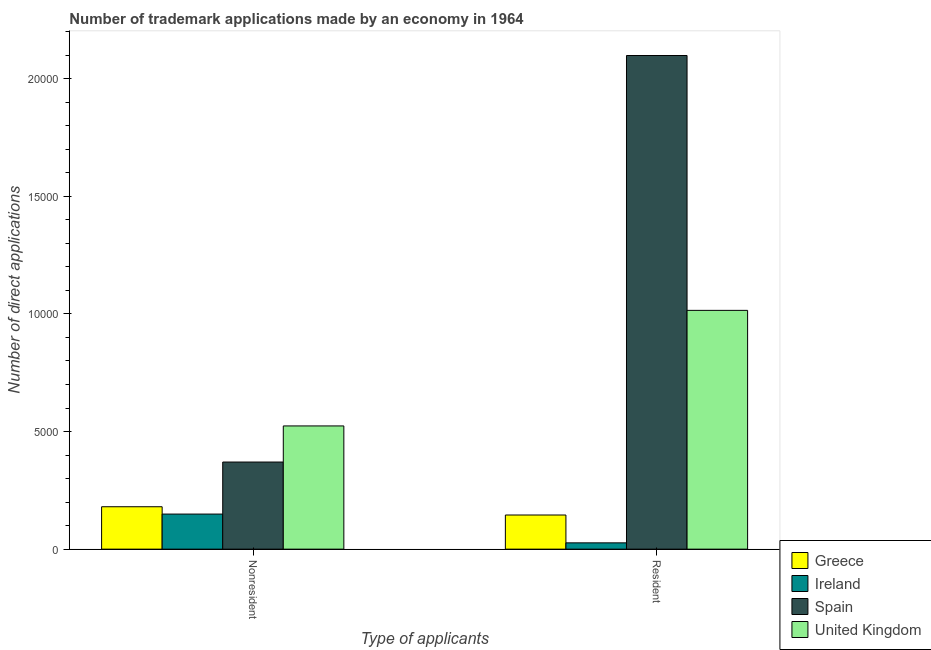How many groups of bars are there?
Provide a succinct answer. 2. Are the number of bars on each tick of the X-axis equal?
Offer a terse response. Yes. How many bars are there on the 2nd tick from the left?
Provide a succinct answer. 4. What is the label of the 2nd group of bars from the left?
Keep it short and to the point. Resident. What is the number of trademark applications made by non residents in Ireland?
Make the answer very short. 1491. Across all countries, what is the maximum number of trademark applications made by non residents?
Make the answer very short. 5238. Across all countries, what is the minimum number of trademark applications made by non residents?
Your answer should be compact. 1491. In which country was the number of trademark applications made by residents maximum?
Offer a very short reply. Spain. In which country was the number of trademark applications made by residents minimum?
Your answer should be very brief. Ireland. What is the total number of trademark applications made by residents in the graph?
Provide a succinct answer. 3.29e+04. What is the difference between the number of trademark applications made by non residents in Ireland and that in Spain?
Keep it short and to the point. -2212. What is the difference between the number of trademark applications made by residents in Greece and the number of trademark applications made by non residents in Spain?
Make the answer very short. -2252. What is the average number of trademark applications made by non residents per country?
Make the answer very short. 3058.75. What is the difference between the number of trademark applications made by non residents and number of trademark applications made by residents in Ireland?
Make the answer very short. 1223. What is the ratio of the number of trademark applications made by residents in Greece to that in United Kingdom?
Your response must be concise. 0.14. What does the 1st bar from the left in Nonresident represents?
Ensure brevity in your answer.  Greece. How many countries are there in the graph?
Offer a very short reply. 4. What is the difference between two consecutive major ticks on the Y-axis?
Make the answer very short. 5000. Does the graph contain any zero values?
Ensure brevity in your answer.  No. How many legend labels are there?
Your response must be concise. 4. How are the legend labels stacked?
Make the answer very short. Vertical. What is the title of the graph?
Give a very brief answer. Number of trademark applications made by an economy in 1964. What is the label or title of the X-axis?
Provide a short and direct response. Type of applicants. What is the label or title of the Y-axis?
Give a very brief answer. Number of direct applications. What is the Number of direct applications of Greece in Nonresident?
Your answer should be very brief. 1803. What is the Number of direct applications of Ireland in Nonresident?
Provide a short and direct response. 1491. What is the Number of direct applications of Spain in Nonresident?
Provide a short and direct response. 3703. What is the Number of direct applications in United Kingdom in Nonresident?
Offer a very short reply. 5238. What is the Number of direct applications in Greece in Resident?
Provide a succinct answer. 1451. What is the Number of direct applications of Ireland in Resident?
Keep it short and to the point. 268. What is the Number of direct applications of Spain in Resident?
Offer a very short reply. 2.10e+04. What is the Number of direct applications of United Kingdom in Resident?
Provide a succinct answer. 1.02e+04. Across all Type of applicants, what is the maximum Number of direct applications of Greece?
Offer a terse response. 1803. Across all Type of applicants, what is the maximum Number of direct applications in Ireland?
Your answer should be very brief. 1491. Across all Type of applicants, what is the maximum Number of direct applications of Spain?
Offer a terse response. 2.10e+04. Across all Type of applicants, what is the maximum Number of direct applications of United Kingdom?
Offer a terse response. 1.02e+04. Across all Type of applicants, what is the minimum Number of direct applications of Greece?
Ensure brevity in your answer.  1451. Across all Type of applicants, what is the minimum Number of direct applications in Ireland?
Offer a terse response. 268. Across all Type of applicants, what is the minimum Number of direct applications in Spain?
Provide a succinct answer. 3703. Across all Type of applicants, what is the minimum Number of direct applications of United Kingdom?
Provide a succinct answer. 5238. What is the total Number of direct applications in Greece in the graph?
Give a very brief answer. 3254. What is the total Number of direct applications in Ireland in the graph?
Your response must be concise. 1759. What is the total Number of direct applications of Spain in the graph?
Provide a short and direct response. 2.47e+04. What is the total Number of direct applications in United Kingdom in the graph?
Provide a succinct answer. 1.54e+04. What is the difference between the Number of direct applications of Greece in Nonresident and that in Resident?
Make the answer very short. 352. What is the difference between the Number of direct applications of Ireland in Nonresident and that in Resident?
Make the answer very short. 1223. What is the difference between the Number of direct applications in Spain in Nonresident and that in Resident?
Give a very brief answer. -1.73e+04. What is the difference between the Number of direct applications in United Kingdom in Nonresident and that in Resident?
Provide a succinct answer. -4912. What is the difference between the Number of direct applications of Greece in Nonresident and the Number of direct applications of Ireland in Resident?
Offer a very short reply. 1535. What is the difference between the Number of direct applications in Greece in Nonresident and the Number of direct applications in Spain in Resident?
Offer a very short reply. -1.92e+04. What is the difference between the Number of direct applications of Greece in Nonresident and the Number of direct applications of United Kingdom in Resident?
Ensure brevity in your answer.  -8347. What is the difference between the Number of direct applications in Ireland in Nonresident and the Number of direct applications in Spain in Resident?
Keep it short and to the point. -1.95e+04. What is the difference between the Number of direct applications in Ireland in Nonresident and the Number of direct applications in United Kingdom in Resident?
Make the answer very short. -8659. What is the difference between the Number of direct applications of Spain in Nonresident and the Number of direct applications of United Kingdom in Resident?
Your response must be concise. -6447. What is the average Number of direct applications of Greece per Type of applicants?
Offer a terse response. 1627. What is the average Number of direct applications in Ireland per Type of applicants?
Give a very brief answer. 879.5. What is the average Number of direct applications in Spain per Type of applicants?
Provide a succinct answer. 1.23e+04. What is the average Number of direct applications in United Kingdom per Type of applicants?
Your answer should be very brief. 7694. What is the difference between the Number of direct applications in Greece and Number of direct applications in Ireland in Nonresident?
Keep it short and to the point. 312. What is the difference between the Number of direct applications in Greece and Number of direct applications in Spain in Nonresident?
Provide a short and direct response. -1900. What is the difference between the Number of direct applications of Greece and Number of direct applications of United Kingdom in Nonresident?
Offer a very short reply. -3435. What is the difference between the Number of direct applications of Ireland and Number of direct applications of Spain in Nonresident?
Make the answer very short. -2212. What is the difference between the Number of direct applications in Ireland and Number of direct applications in United Kingdom in Nonresident?
Your response must be concise. -3747. What is the difference between the Number of direct applications in Spain and Number of direct applications in United Kingdom in Nonresident?
Provide a succinct answer. -1535. What is the difference between the Number of direct applications of Greece and Number of direct applications of Ireland in Resident?
Your answer should be very brief. 1183. What is the difference between the Number of direct applications in Greece and Number of direct applications in Spain in Resident?
Keep it short and to the point. -1.95e+04. What is the difference between the Number of direct applications of Greece and Number of direct applications of United Kingdom in Resident?
Give a very brief answer. -8699. What is the difference between the Number of direct applications in Ireland and Number of direct applications in Spain in Resident?
Provide a short and direct response. -2.07e+04. What is the difference between the Number of direct applications of Ireland and Number of direct applications of United Kingdom in Resident?
Ensure brevity in your answer.  -9882. What is the difference between the Number of direct applications of Spain and Number of direct applications of United Kingdom in Resident?
Give a very brief answer. 1.08e+04. What is the ratio of the Number of direct applications of Greece in Nonresident to that in Resident?
Provide a short and direct response. 1.24. What is the ratio of the Number of direct applications in Ireland in Nonresident to that in Resident?
Keep it short and to the point. 5.56. What is the ratio of the Number of direct applications of Spain in Nonresident to that in Resident?
Make the answer very short. 0.18. What is the ratio of the Number of direct applications in United Kingdom in Nonresident to that in Resident?
Give a very brief answer. 0.52. What is the difference between the highest and the second highest Number of direct applications of Greece?
Your answer should be very brief. 352. What is the difference between the highest and the second highest Number of direct applications in Ireland?
Offer a terse response. 1223. What is the difference between the highest and the second highest Number of direct applications in Spain?
Your response must be concise. 1.73e+04. What is the difference between the highest and the second highest Number of direct applications in United Kingdom?
Your answer should be compact. 4912. What is the difference between the highest and the lowest Number of direct applications in Greece?
Give a very brief answer. 352. What is the difference between the highest and the lowest Number of direct applications in Ireland?
Provide a succinct answer. 1223. What is the difference between the highest and the lowest Number of direct applications in Spain?
Ensure brevity in your answer.  1.73e+04. What is the difference between the highest and the lowest Number of direct applications of United Kingdom?
Keep it short and to the point. 4912. 